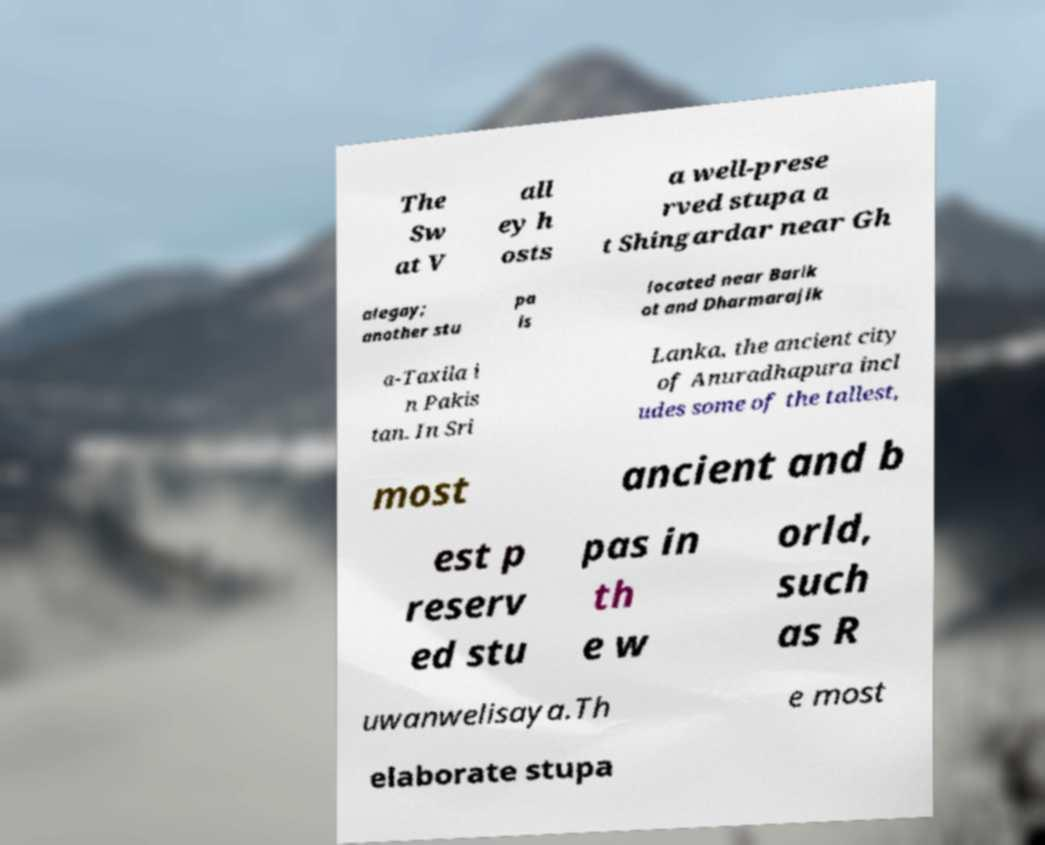I need the written content from this picture converted into text. Can you do that? The Sw at V all ey h osts a well-prese rved stupa a t Shingardar near Gh alegay; another stu pa is located near Barik ot and Dharmarajik a-Taxila i n Pakis tan. In Sri Lanka, the ancient city of Anuradhapura incl udes some of the tallest, most ancient and b est p reserv ed stu pas in th e w orld, such as R uwanwelisaya.Th e most elaborate stupa 